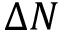<formula> <loc_0><loc_0><loc_500><loc_500>\Delta N</formula> 